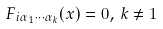<formula> <loc_0><loc_0><loc_500><loc_500>F _ { i \alpha _ { 1 } \cdots \alpha _ { k } } ( x ) = 0 , \, k \neq 1</formula> 